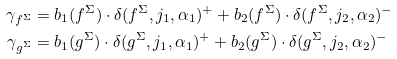Convert formula to latex. <formula><loc_0><loc_0><loc_500><loc_500>\gamma _ { f ^ { \Sigma } } & = b _ { 1 } ( f ^ { \Sigma } ) \cdot \delta ( f ^ { \Sigma } , j _ { 1 } , \alpha _ { 1 } ) ^ { + } + b _ { 2 } ( f ^ { \Sigma } ) \cdot \delta ( f ^ { \Sigma } , j _ { 2 } , \alpha _ { 2 } ) ^ { - } \\ \gamma _ { g ^ { \Sigma } } & = b _ { 1 } ( g ^ { \Sigma } ) \cdot \delta ( g ^ { \Sigma } , j _ { 1 } , \alpha _ { 1 } ) ^ { + } + b _ { 2 } ( g ^ { \Sigma } ) \cdot \delta ( g ^ { \Sigma } , j _ { 2 } , \alpha _ { 2 } ) ^ { - }</formula> 